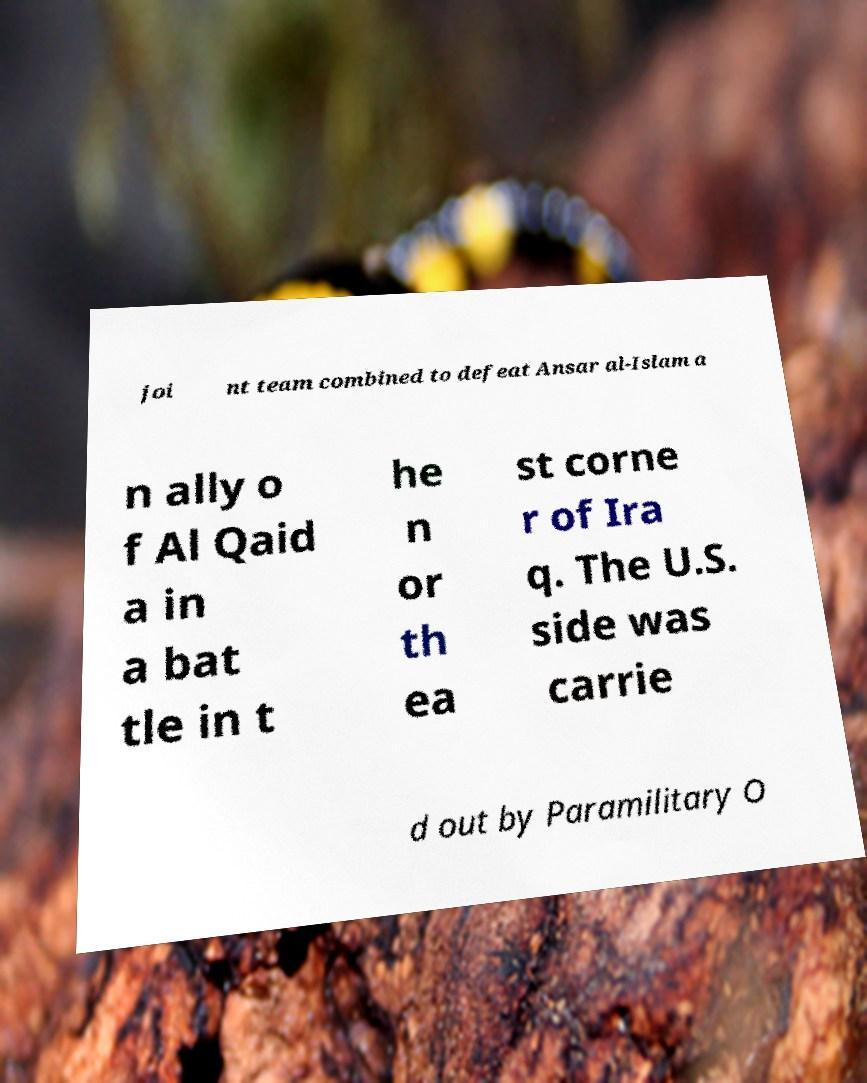Can you accurately transcribe the text from the provided image for me? joi nt team combined to defeat Ansar al-Islam a n ally o f Al Qaid a in a bat tle in t he n or th ea st corne r of Ira q. The U.S. side was carrie d out by Paramilitary O 